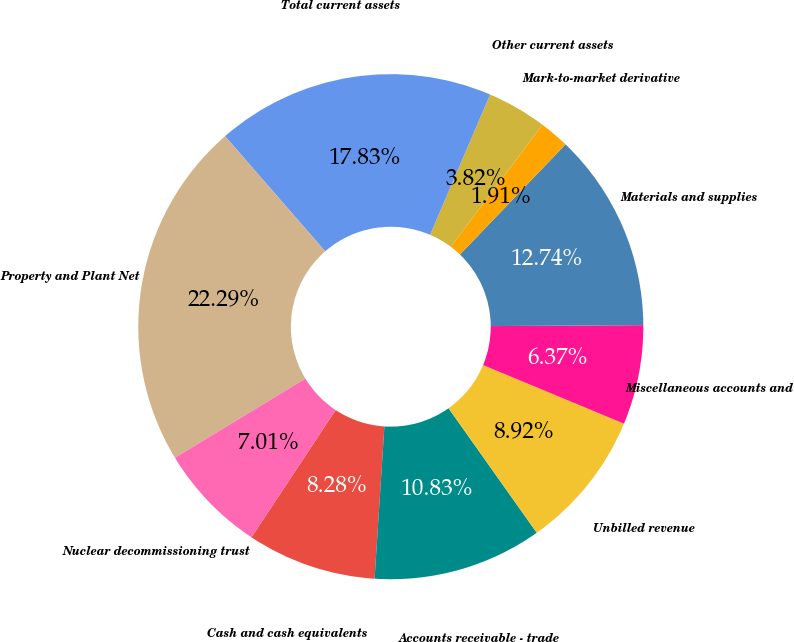Convert chart. <chart><loc_0><loc_0><loc_500><loc_500><pie_chart><fcel>Cash and cash equivalents<fcel>Accounts receivable - trade<fcel>Unbilled revenue<fcel>Miscellaneous accounts and<fcel>Materials and supplies<fcel>Mark-to-market derivative<fcel>Other current assets<fcel>Total current assets<fcel>Property and Plant Net<fcel>Nuclear decommissioning trust<nl><fcel>8.28%<fcel>10.83%<fcel>8.92%<fcel>6.37%<fcel>12.74%<fcel>1.91%<fcel>3.82%<fcel>17.83%<fcel>22.29%<fcel>7.01%<nl></chart> 